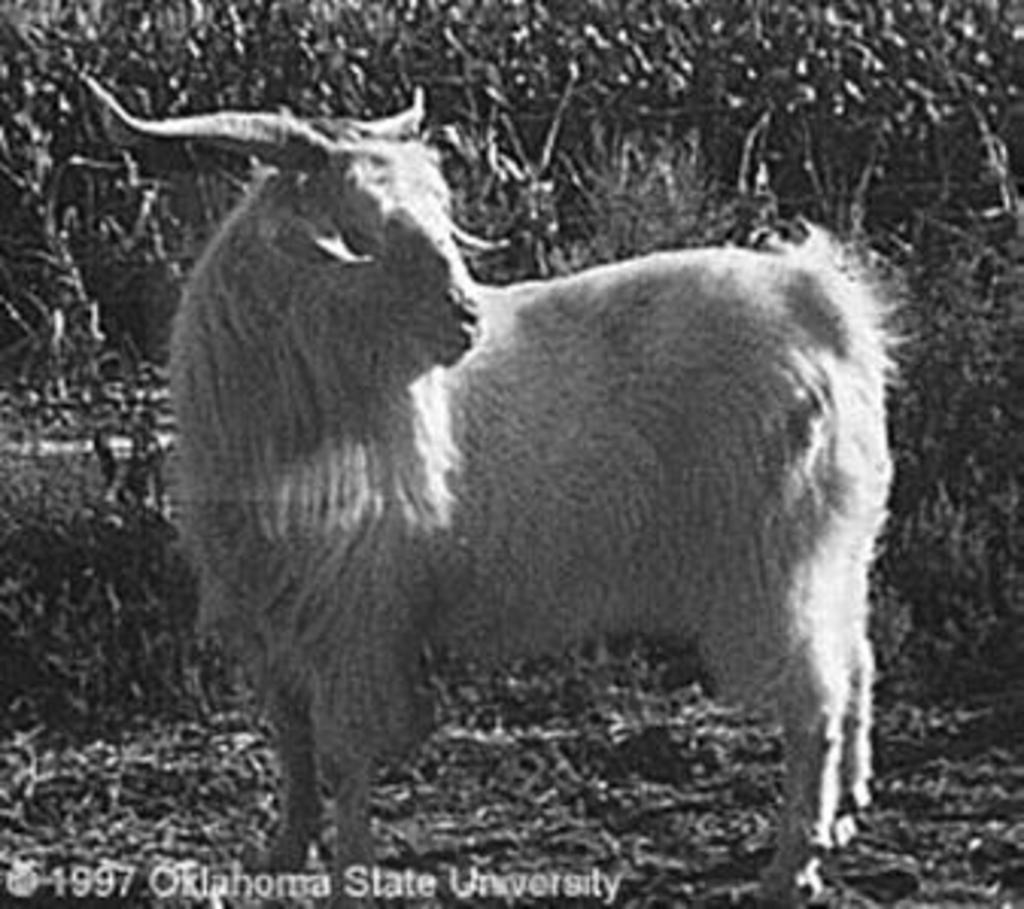What is the main subject in the center of the image? There is an animal in the center of the image. What can be seen in the background of the image? There are plants in the background of the image. What type of tray is being exchanged between the plants in the image? There is no tray or exchange between plants present in the image; it features an animal in the center and plants in the background. 